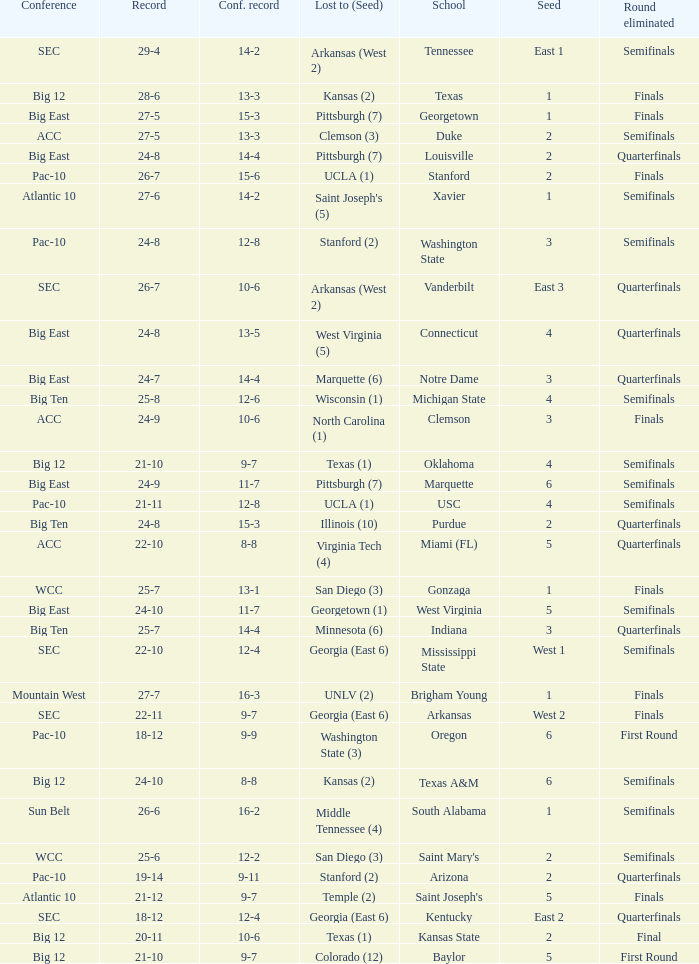Name the school where conference record is 12-6 Michigan State. 